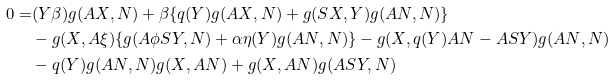Convert formula to latex. <formula><loc_0><loc_0><loc_500><loc_500>0 = & ( Y { \beta } ) g ( A X , N ) + { \beta } \{ q ( Y ) g ( A X , N ) + g ( S X , Y ) g ( A N , N ) \} \\ & - g ( X , A { \xi } ) \{ g ( A { \phi } S Y , N ) + { \alpha } { \eta } ( Y ) g ( A N , N ) \} - g ( X , q ( Y ) A N - A S Y ) g ( A N , N ) \\ & - q ( Y ) g ( A N , N ) g ( X , A N ) + g ( X , A N ) g ( A S Y , N )</formula> 